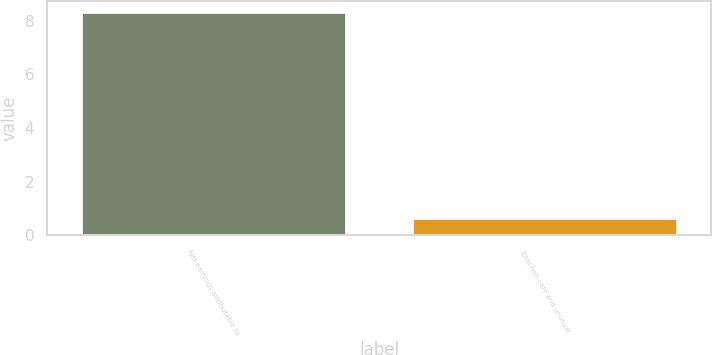Convert chart. <chart><loc_0><loc_0><loc_500><loc_500><bar_chart><fcel>Net earnings attributable to<fcel>Total non-core and unusual<nl><fcel>8.32<fcel>0.64<nl></chart> 